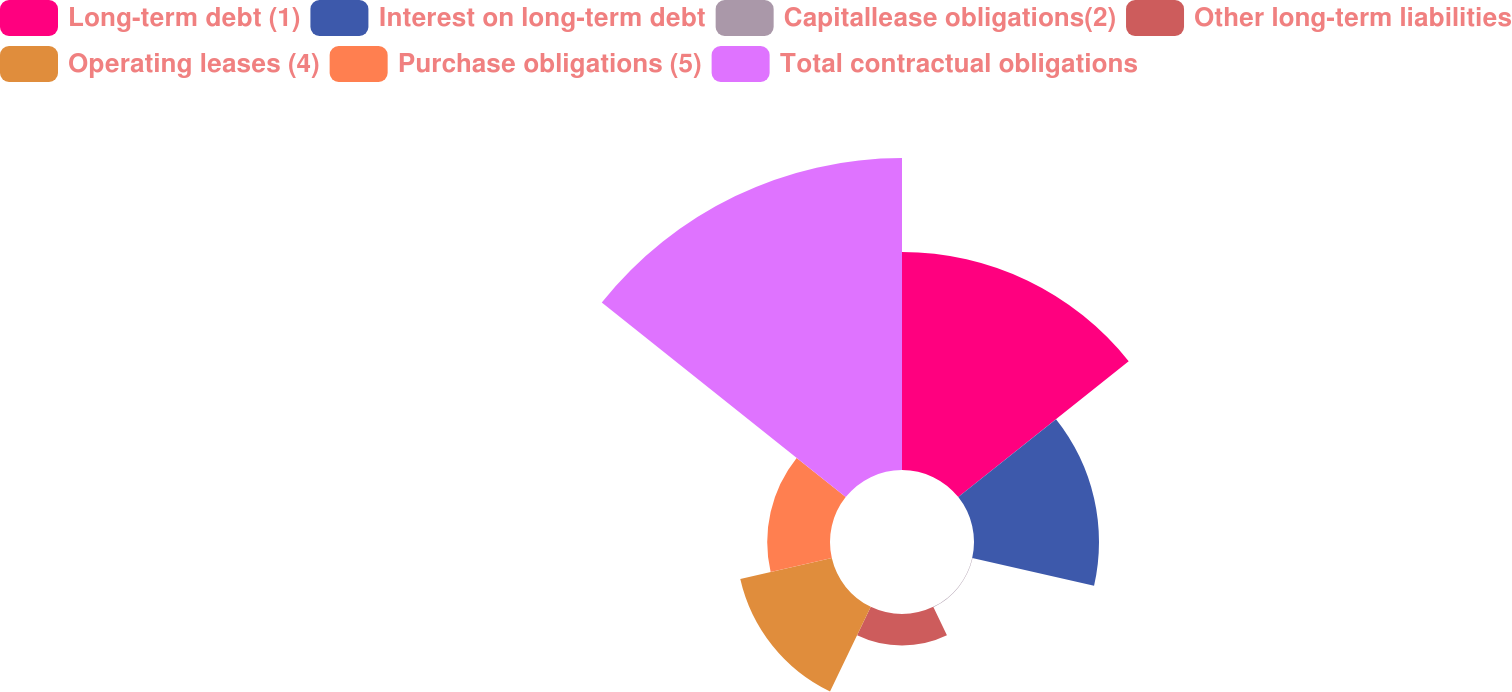Convert chart to OTSL. <chart><loc_0><loc_0><loc_500><loc_500><pie_chart><fcel>Long-term debt (1)<fcel>Interest on long-term debt<fcel>Capitallease obligations(2)<fcel>Other long-term liabilities<fcel>Operating leases (4)<fcel>Purchase obligations (5)<fcel>Total contractual obligations<nl><fcel>25.84%<fcel>14.82%<fcel>0.05%<fcel>3.74%<fcel>11.13%<fcel>7.44%<fcel>36.99%<nl></chart> 